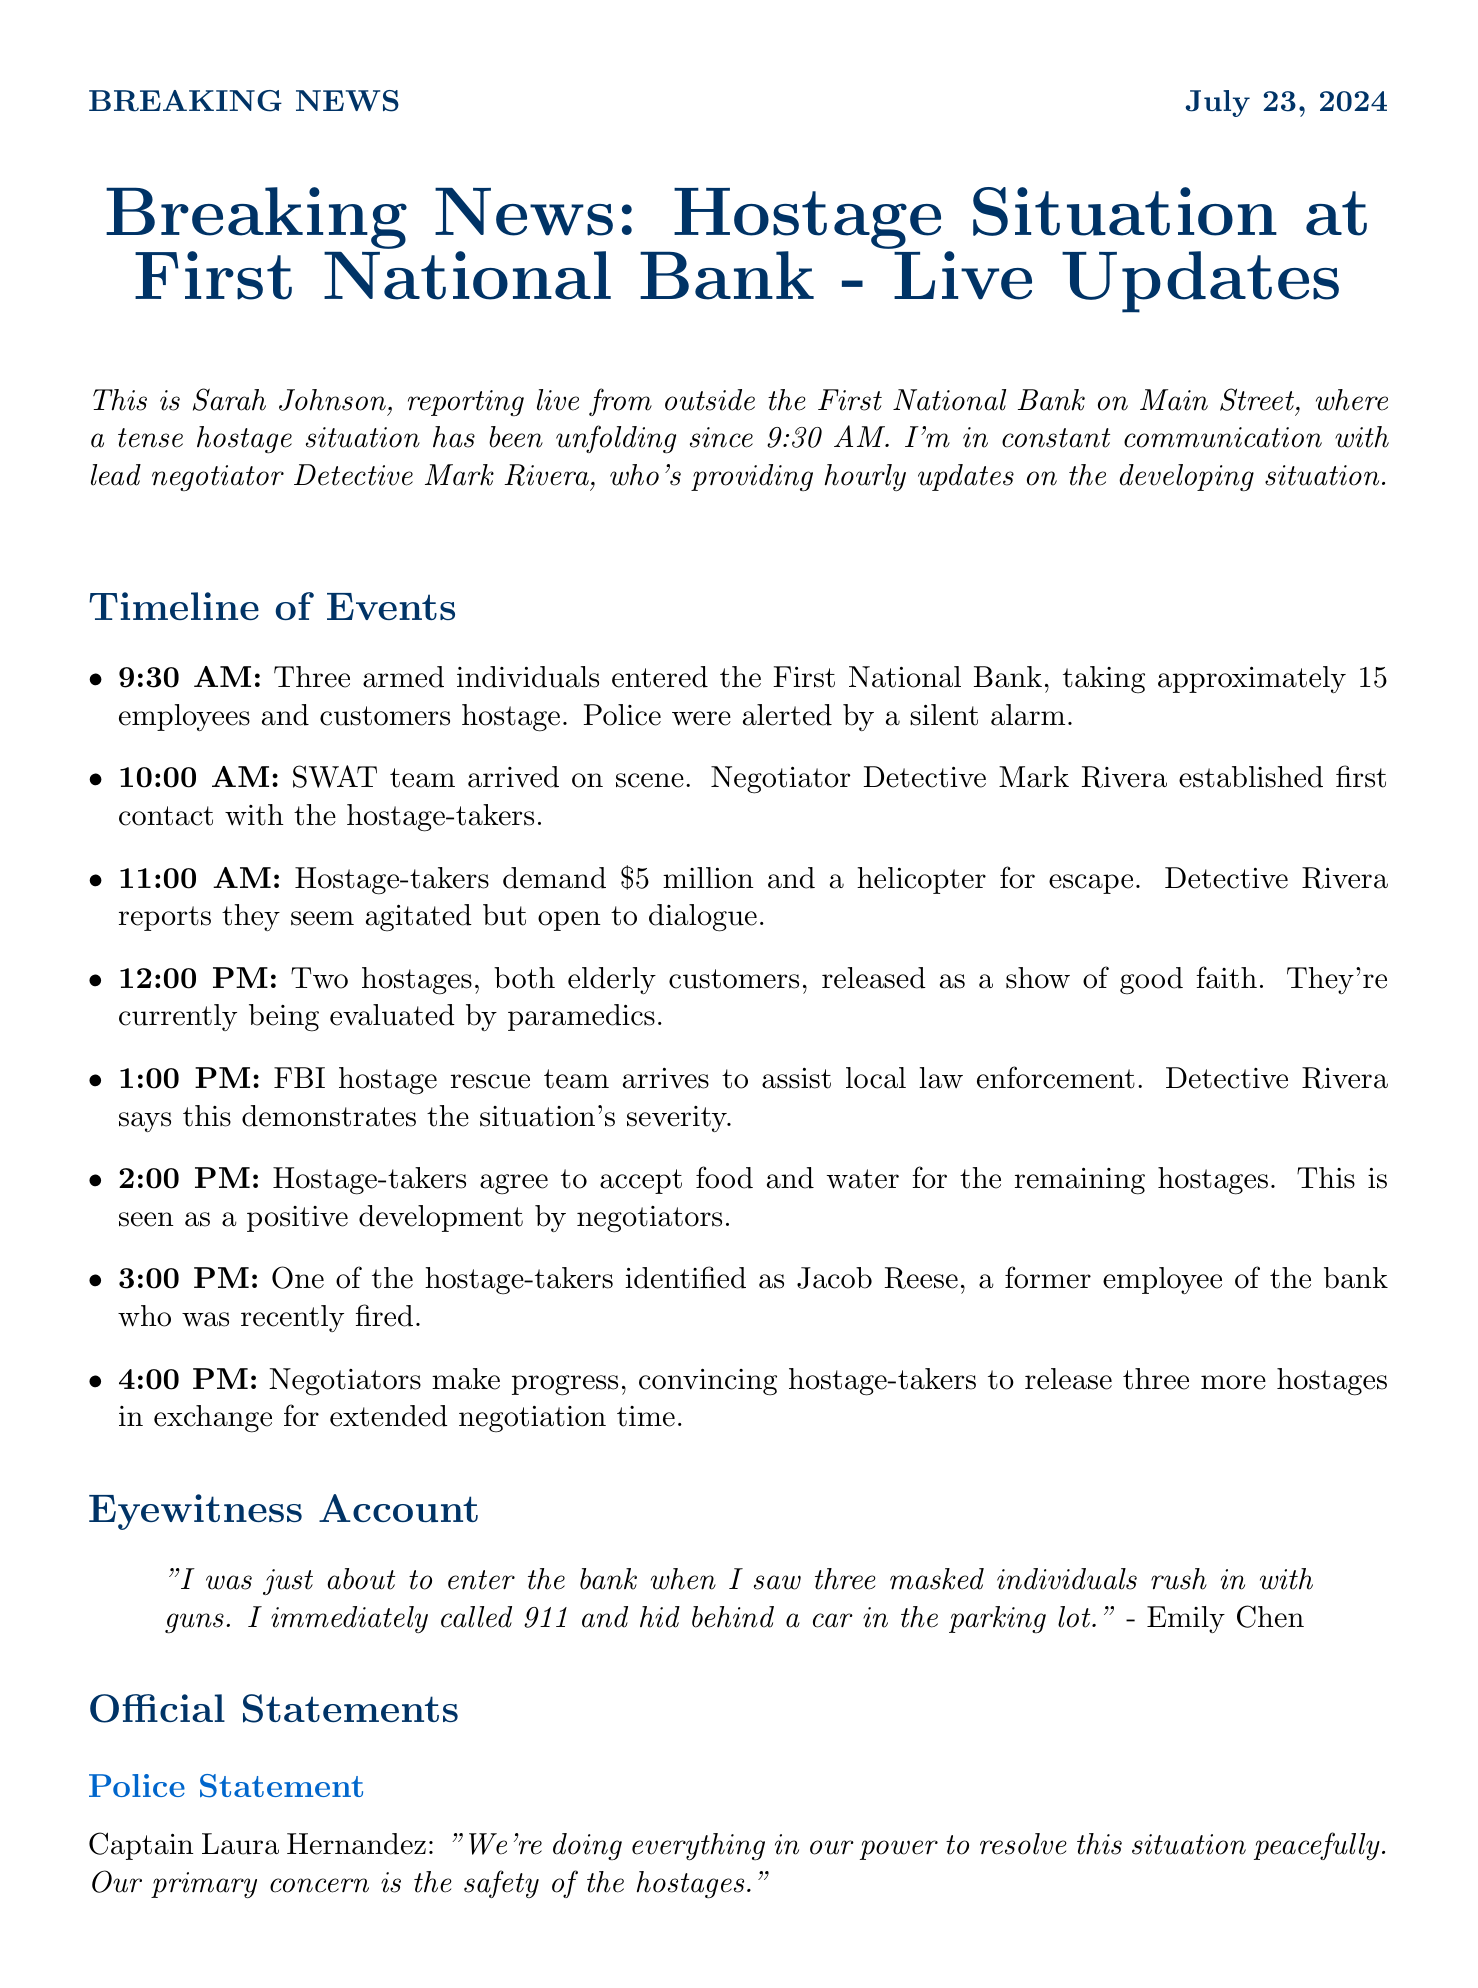what time did the hostage situation begin? The hostage situation began at 9:30 AM, as stated in the timeline of events.
Answer: 9:30 AM how many hostages were initially taken? Approximately 15 employees and customers were taken hostage according to the first update.
Answer: 15 who is the lead negotiator? Detective Mark Rivera is identified as the lead negotiator in the document.
Answer: Detective Mark Rivera how much money did the hostage-takers demand? The hostage-takers demanded $5 million, as mentioned in the timeline.
Answer: $5 million what positive development occurred at 2:00 PM? At 2:00 PM, the hostage-takers agreed to accept food and water for the remaining hostages, indicating progress in negotiations.
Answer: Agreed to accept food and water what is the name of the eyewitness? Emily Chen is named as the eyewitness who provided an account of the situation.
Answer: Emily Chen which school closures were mentioned? Central High School and Washington Elementary were listed as closed due to the situation.
Answer: Central High School, Washington Elementary what resources were deployed for emergency services? The document lists the Fire Department, Paramedics, and Crisis Counselors as emergency services deployed.
Answer: Fire Department, Paramedics, Crisis Counselors who made a statement on behalf of the bank? Michael Thompson, the VP of Communications, made a statement on behalf of the bank.
Answer: Michael Thompson 